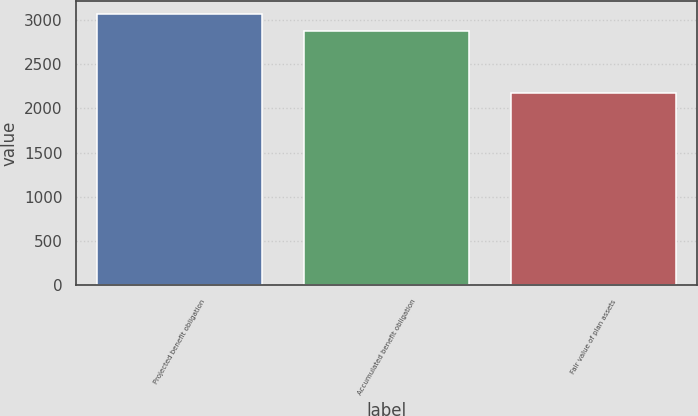Convert chart to OTSL. <chart><loc_0><loc_0><loc_500><loc_500><bar_chart><fcel>Projected benefit obligation<fcel>Accumulated benefit obligation<fcel>Fair value of plan assets<nl><fcel>3064.4<fcel>2876.2<fcel>2172.7<nl></chart> 